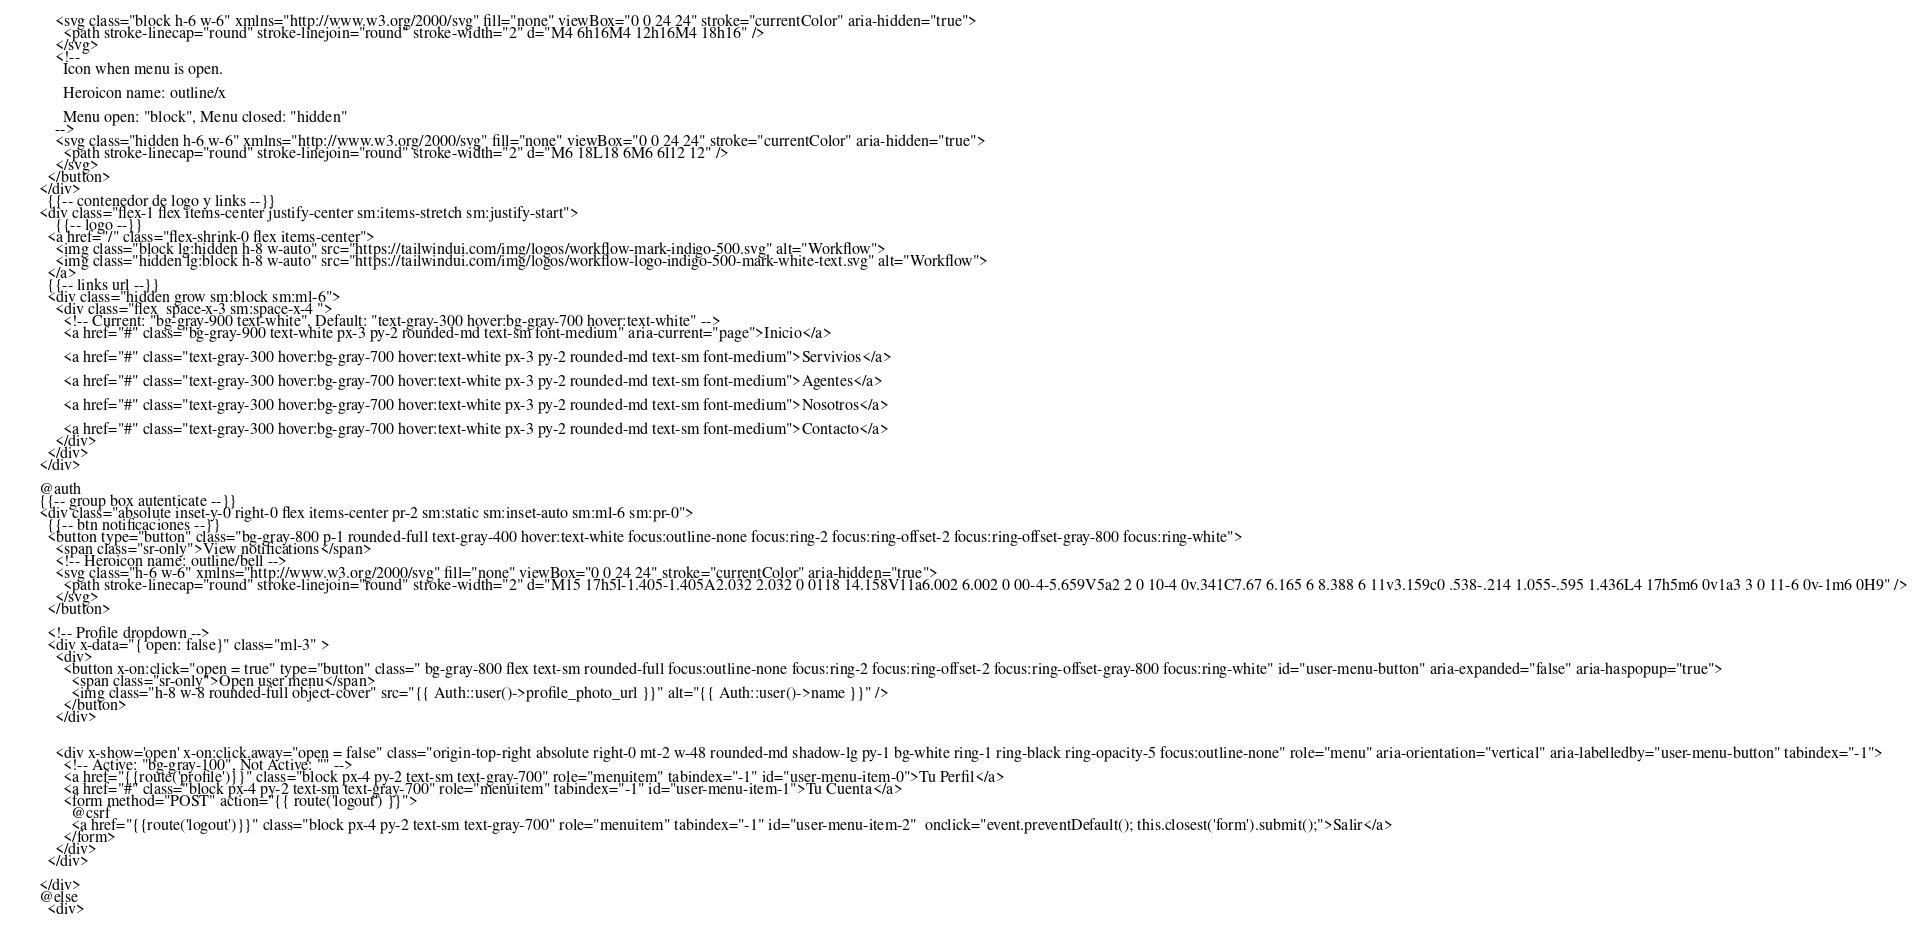<code> <loc_0><loc_0><loc_500><loc_500><_PHP_>          <svg class="block h-6 w-6" xmlns="http://www.w3.org/2000/svg" fill="none" viewBox="0 0 24 24" stroke="currentColor" aria-hidden="true">
            <path stroke-linecap="round" stroke-linejoin="round" stroke-width="2" d="M4 6h16M4 12h16M4 18h16" />
          </svg>
          <!--
            Icon when menu is open.

            Heroicon name: outline/x

            Menu open: "block", Menu closed: "hidden"
          -->
          <svg class="hidden h-6 w-6" xmlns="http://www.w3.org/2000/svg" fill="none" viewBox="0 0 24 24" stroke="currentColor" aria-hidden="true">
            <path stroke-linecap="round" stroke-linejoin="round" stroke-width="2" d="M6 18L18 6M6 6l12 12" />
          </svg>
        </button>
      </div>
        {{-- contenedor de logo y links --}}
      <div class="flex-1 flex items-center justify-center sm:items-stretch sm:justify-start">
          {{-- logo --}}
        <a href="/" class="flex-shrink-0 flex items-center">
          <img class="block lg:hidden h-8 w-auto" src="https://tailwindui.com/img/logos/workflow-mark-indigo-500.svg" alt="Workflow">
          <img class="hidden lg:block h-8 w-auto" src="https://tailwindui.com/img/logos/workflow-logo-indigo-500-mark-white-text.svg" alt="Workflow">
        </a>
        {{-- links url --}}
        <div class="hidden grow sm:block sm:ml-6">
          <div class="flex  space-x-3 sm:space-x-4 ">
            <!-- Current: "bg-gray-900 text-white", Default: "text-gray-300 hover:bg-gray-700 hover:text-white" -->
            <a href="#" class="bg-gray-900 text-white px-3 py-2 rounded-md text-sm font-medium" aria-current="page">Inicio</a>

            <a href="#" class="text-gray-300 hover:bg-gray-700 hover:text-white px-3 py-2 rounded-md text-sm font-medium">Servivios</a>

            <a href="#" class="text-gray-300 hover:bg-gray-700 hover:text-white px-3 py-2 rounded-md text-sm font-medium">Agentes</a>

            <a href="#" class="text-gray-300 hover:bg-gray-700 hover:text-white px-3 py-2 rounded-md text-sm font-medium">Nosotros</a>

            <a href="#" class="text-gray-300 hover:bg-gray-700 hover:text-white px-3 py-2 rounded-md text-sm font-medium">Contacto</a>
          </div>
        </div>
      </div>

      @auth
      {{-- group box autenticate --}}
      <div class="absolute inset-y-0 right-0 flex items-center pr-2 sm:static sm:inset-auto sm:ml-6 sm:pr-0">
        {{-- btn notificaciones --}}
        <button type="button" class="bg-gray-800 p-1 rounded-full text-gray-400 hover:text-white focus:outline-none focus:ring-2 focus:ring-offset-2 focus:ring-offset-gray-800 focus:ring-white">
          <span class="sr-only">View notifications</span>
          <!-- Heroicon name: outline/bell -->
          <svg class="h-6 w-6" xmlns="http://www.w3.org/2000/svg" fill="none" viewBox="0 0 24 24" stroke="currentColor" aria-hidden="true">
            <path stroke-linecap="round" stroke-linejoin="round" stroke-width="2" d="M15 17h5l-1.405-1.405A2.032 2.032 0 0118 14.158V11a6.002 6.002 0 00-4-5.659V5a2 2 0 10-4 0v.341C7.67 6.165 6 8.388 6 11v3.159c0 .538-.214 1.055-.595 1.436L4 17h5m6 0v1a3 3 0 11-6 0v-1m6 0H9" />
          </svg>
        </button>

        <!-- Profile dropdown -->
        <div x-data="{ open: false}" class="ml-3" >
          <div>
            <button x-on:click="open = true" type="button" class=" bg-gray-800 flex text-sm rounded-full focus:outline-none focus:ring-2 focus:ring-offset-2 focus:ring-offset-gray-800 focus:ring-white" id="user-menu-button" aria-expanded="false" aria-haspopup="true">
              <span class="sr-only">Open user menu</span>
              <img class="h-8 w-8 rounded-full object-cover" src="{{ Auth::user()->profile_photo_url }}" alt="{{ Auth::user()->name }}" />
            </button>
          </div>

 
          <div x-show='open' x-on:click.away="open = false" class="origin-top-right absolute right-0 mt-2 w-48 rounded-md shadow-lg py-1 bg-white ring-1 ring-black ring-opacity-5 focus:outline-none" role="menu" aria-orientation="vertical" aria-labelledby="user-menu-button" tabindex="-1">
            <!-- Active: "bg-gray-100", Not Active: "" -->
            <a href="{{route('profile')}}" class="block px-4 py-2 text-sm text-gray-700" role="menuitem" tabindex="-1" id="user-menu-item-0">Tu Perfil</a>
            <a href="#" class="block px-4 py-2 text-sm text-gray-700" role="menuitem" tabindex="-1" id="user-menu-item-1">Tu Cuenta</a>
            <form method="POST" action="{{ route('logout') }}">
              @csrf
              <a href="{{route('logout')}}" class="block px-4 py-2 text-sm text-gray-700" role="menuitem" tabindex="-1" id="user-menu-item-2"  onclick="event.preventDefault(); this.closest('form').submit();">Salir</a>
            </form>
          </div>
        </div>

      </div>
      @else
        <div></code> 